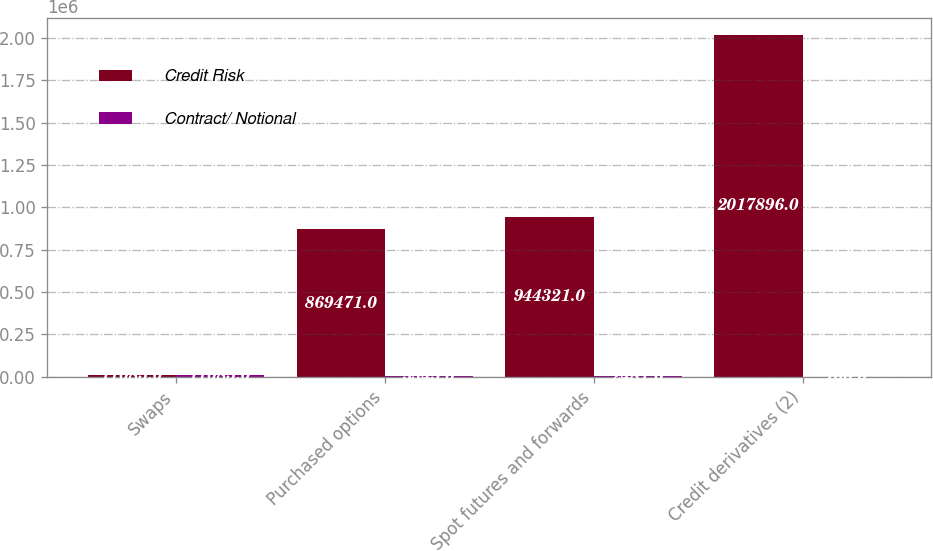Convert chart to OTSL. <chart><loc_0><loc_0><loc_500><loc_500><stacked_bar_chart><ecel><fcel>Swaps<fcel>Purchased options<fcel>Spot futures and forwards<fcel>Credit derivatives (2)<nl><fcel>Credit Risk<fcel>11085<fcel>869471<fcel>944321<fcel>2.0179e+06<nl><fcel>Contract/ Notional<fcel>11085<fcel>3345<fcel>2481<fcel>766<nl></chart> 